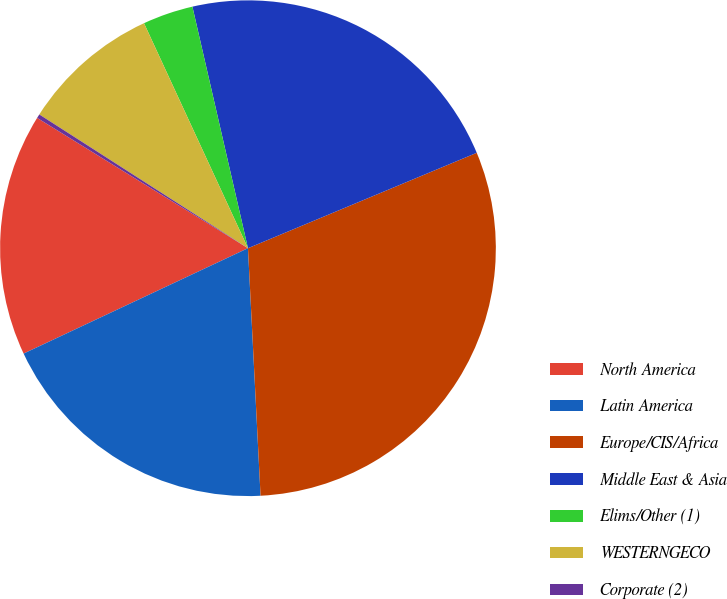<chart> <loc_0><loc_0><loc_500><loc_500><pie_chart><fcel>North America<fcel>Latin America<fcel>Europe/CIS/Africa<fcel>Middle East & Asia<fcel>Elims/Other (1)<fcel>WESTERNGECO<fcel>Corporate (2)<nl><fcel>15.8%<fcel>18.82%<fcel>30.48%<fcel>22.31%<fcel>3.29%<fcel>9.04%<fcel>0.26%<nl></chart> 